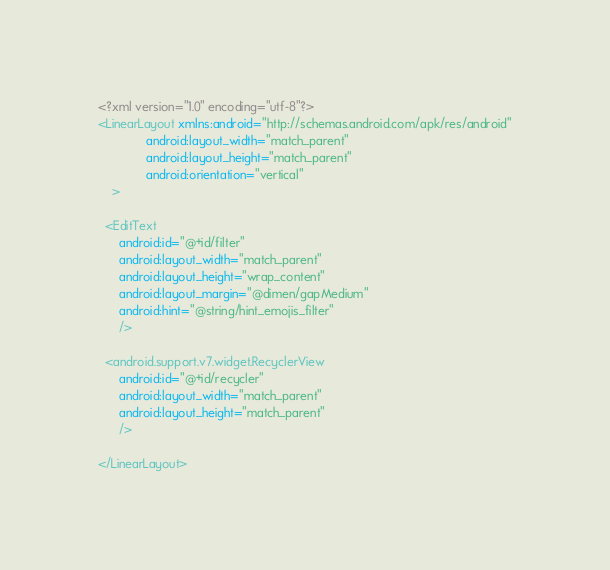Convert code to text. <code><loc_0><loc_0><loc_500><loc_500><_XML_><?xml version="1.0" encoding="utf-8"?>
<LinearLayout xmlns:android="http://schemas.android.com/apk/res/android"
              android:layout_width="match_parent"
              android:layout_height="match_parent"
              android:orientation="vertical"
    >

  <EditText
      android:id="@+id/filter"
      android:layout_width="match_parent"
      android:layout_height="wrap_content"
      android:layout_margin="@dimen/gapMedium"
      android:hint="@string/hint_emojis_filter"
      />

  <android.support.v7.widget.RecyclerView
      android:id="@+id/recycler"
      android:layout_width="match_parent"
      android:layout_height="match_parent"
      />

</LinearLayout></code> 